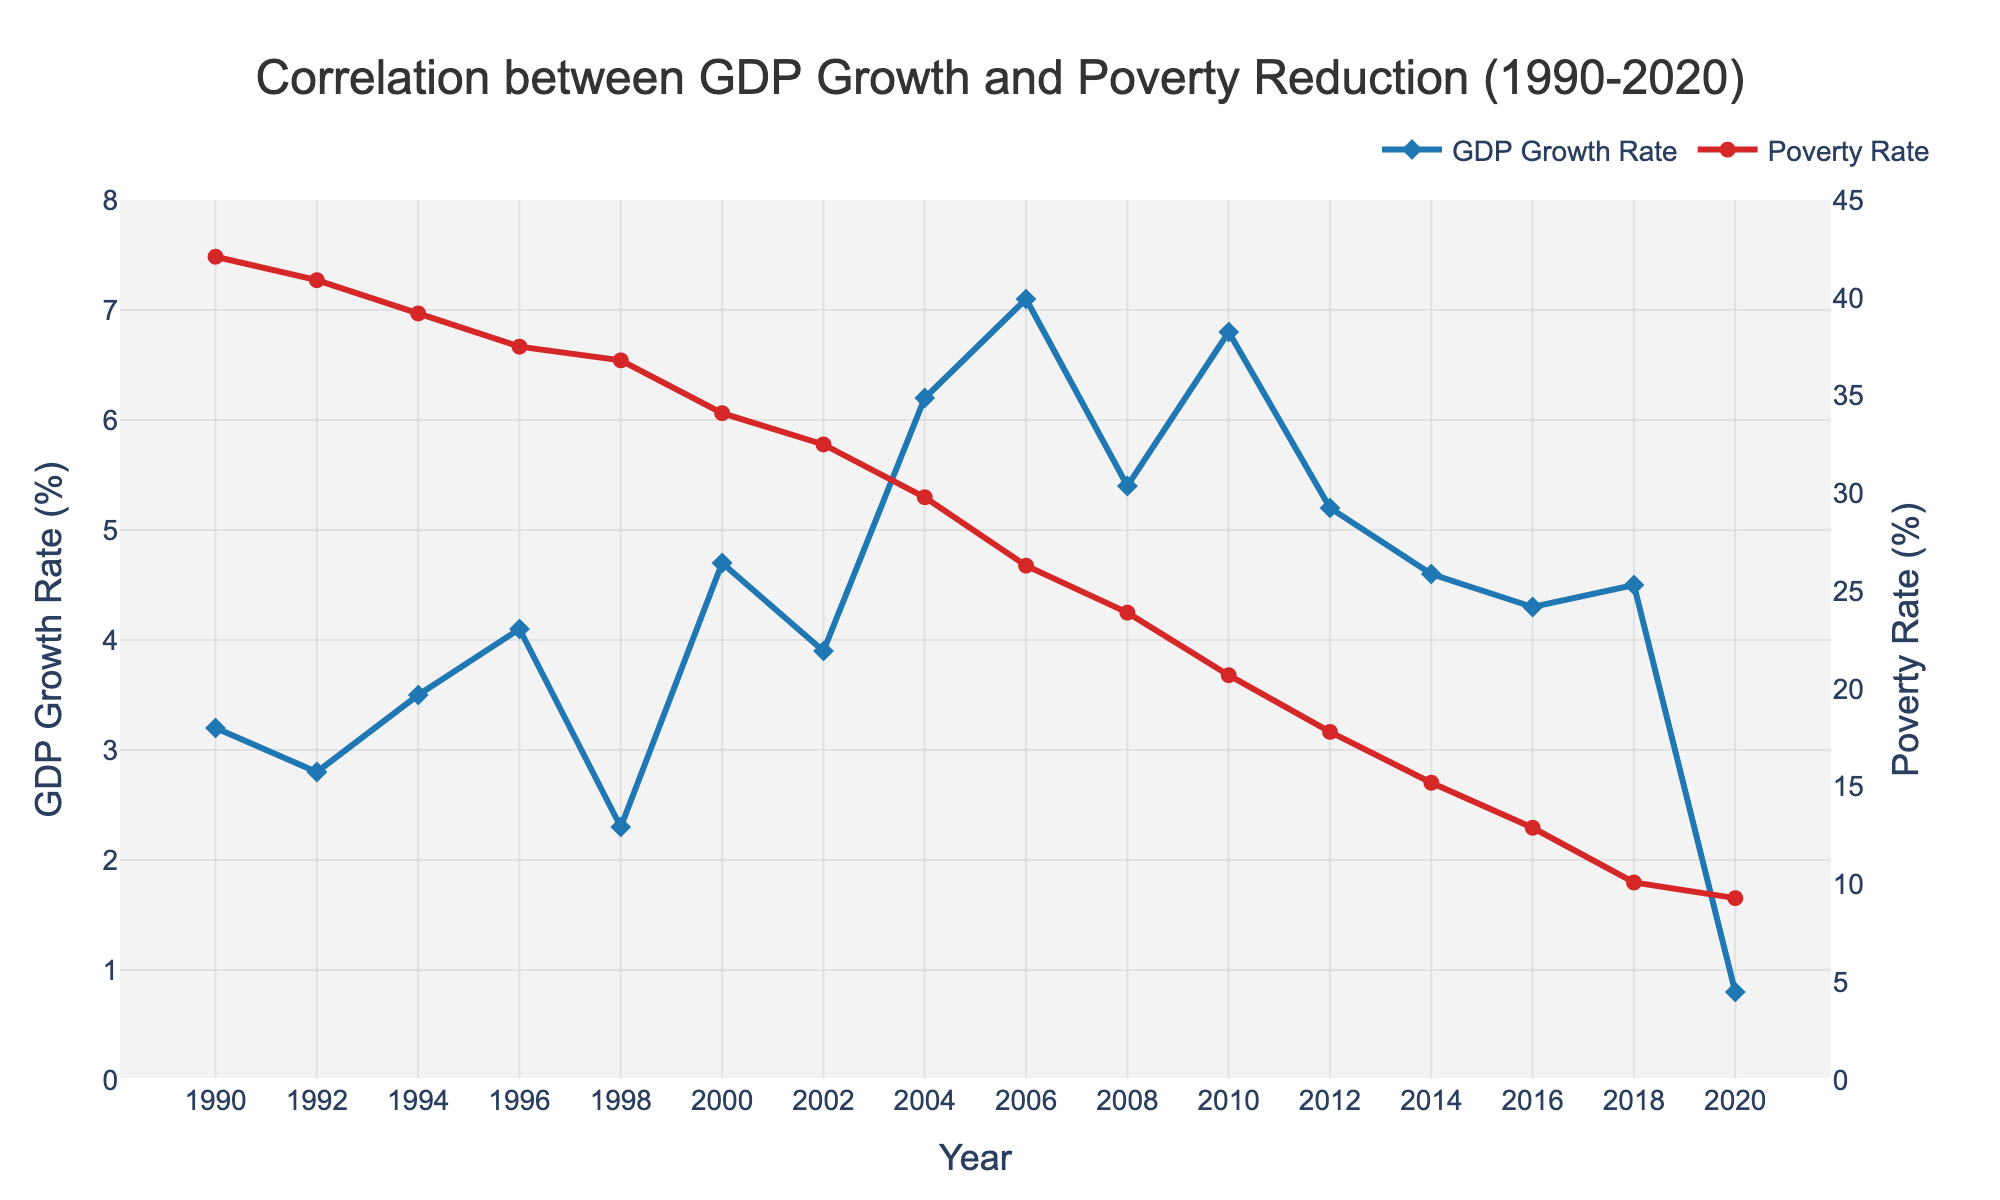What is the trend in GDP Growth Rate from 1990 to 2020? The GDP Growth Rate generally shows an increasing trend with fluctuations. It started at 3.2% in 1990, peaked at 7.1% in 2006, and dropped to 0.8% in 2020.
Answer: Increasing trend overall How does the Poverty Rate change over the years 1990 to 2020? The Poverty Rate shows a decreasing trend from 42.1% in 1990 to 9.3% in 2020.
Answer: Decreasing trend In which year did the GDP Growth Rate peak, and what was the value? The GDP Growth Rate peaked in 2006 at 7.1%.
Answer: 2006, 7.1% Compare the Poverty Rate in 2000 and 2020. Which year had a higher rate and by how much? The Poverty Rate in 2000 was 34.1%, and in 2020 it was 9.3%. The rate was higher in 2000 by 34.1% - 9.3% = 24.8%.
Answer: 2000, 24.8% What was the difference in GDP Growth Rate between 1998 and 2000? The GDP Growth Rate in 1998 was 2.3%, and in 2000 it was 4.7%. The difference is 4.7% - 2.3% = 2.4%.
Answer: 2.4% How did the GDP Growth Rate and Poverty Rate correlate over time? The GDP Growth Rate and Poverty Rate show an inverse correlation over time; as GDP Growth Rate increases, Poverty Rate decreases.
Answer: Inverse correlation What is the average GDP Growth Rate over the three decades? Sum the GDP Growth Rates for all years and divide by the number of data points: (3.2 + 2.8 + 3.5 + 4.1 + 2.3 + 4.7 + 3.9 + 6.2 + 7.1 + 5.4 + 6.8 + 5.2 + 4.6 + 4.3 + 4.5 + 0.8) / 16 = 4.34%.
Answer: 4.34% Which year experienced the largest drop in Poverty Rate compared to the previous year? The largest drop is observed from 2010 to 2012, with a decrease from 20.7% to 17.8%, a difference of 2.9%.
Answer: 2010-2012, 2.9% 